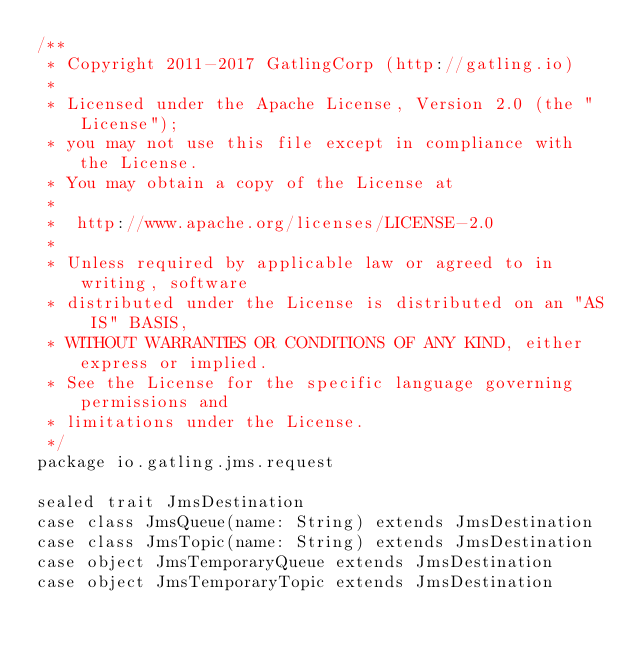<code> <loc_0><loc_0><loc_500><loc_500><_Scala_>/**
 * Copyright 2011-2017 GatlingCorp (http://gatling.io)
 *
 * Licensed under the Apache License, Version 2.0 (the "License");
 * you may not use this file except in compliance with the License.
 * You may obtain a copy of the License at
 *
 *  http://www.apache.org/licenses/LICENSE-2.0
 *
 * Unless required by applicable law or agreed to in writing, software
 * distributed under the License is distributed on an "AS IS" BASIS,
 * WITHOUT WARRANTIES OR CONDITIONS OF ANY KIND, either express or implied.
 * See the License for the specific language governing permissions and
 * limitations under the License.
 */
package io.gatling.jms.request

sealed trait JmsDestination
case class JmsQueue(name: String) extends JmsDestination
case class JmsTopic(name: String) extends JmsDestination
case object JmsTemporaryQueue extends JmsDestination
case object JmsTemporaryTopic extends JmsDestination
</code> 